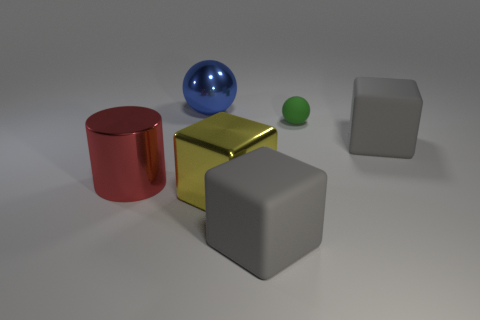Add 1 big brown rubber spheres. How many objects exist? 7 Subtract all spheres. How many objects are left? 4 Add 3 big gray things. How many big gray things are left? 5 Add 6 balls. How many balls exist? 8 Subtract 0 cyan cubes. How many objects are left? 6 Subtract all yellow metallic things. Subtract all large cylinders. How many objects are left? 4 